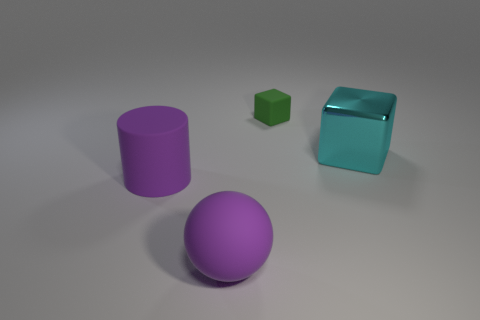Add 4 big yellow spheres. How many objects exist? 8 Subtract all balls. How many objects are left? 3 Add 4 large purple matte cylinders. How many large purple matte cylinders are left? 5 Add 4 cyan shiny cylinders. How many cyan shiny cylinders exist? 4 Subtract 0 blue balls. How many objects are left? 4 Subtract all green matte cylinders. Subtract all cyan cubes. How many objects are left? 3 